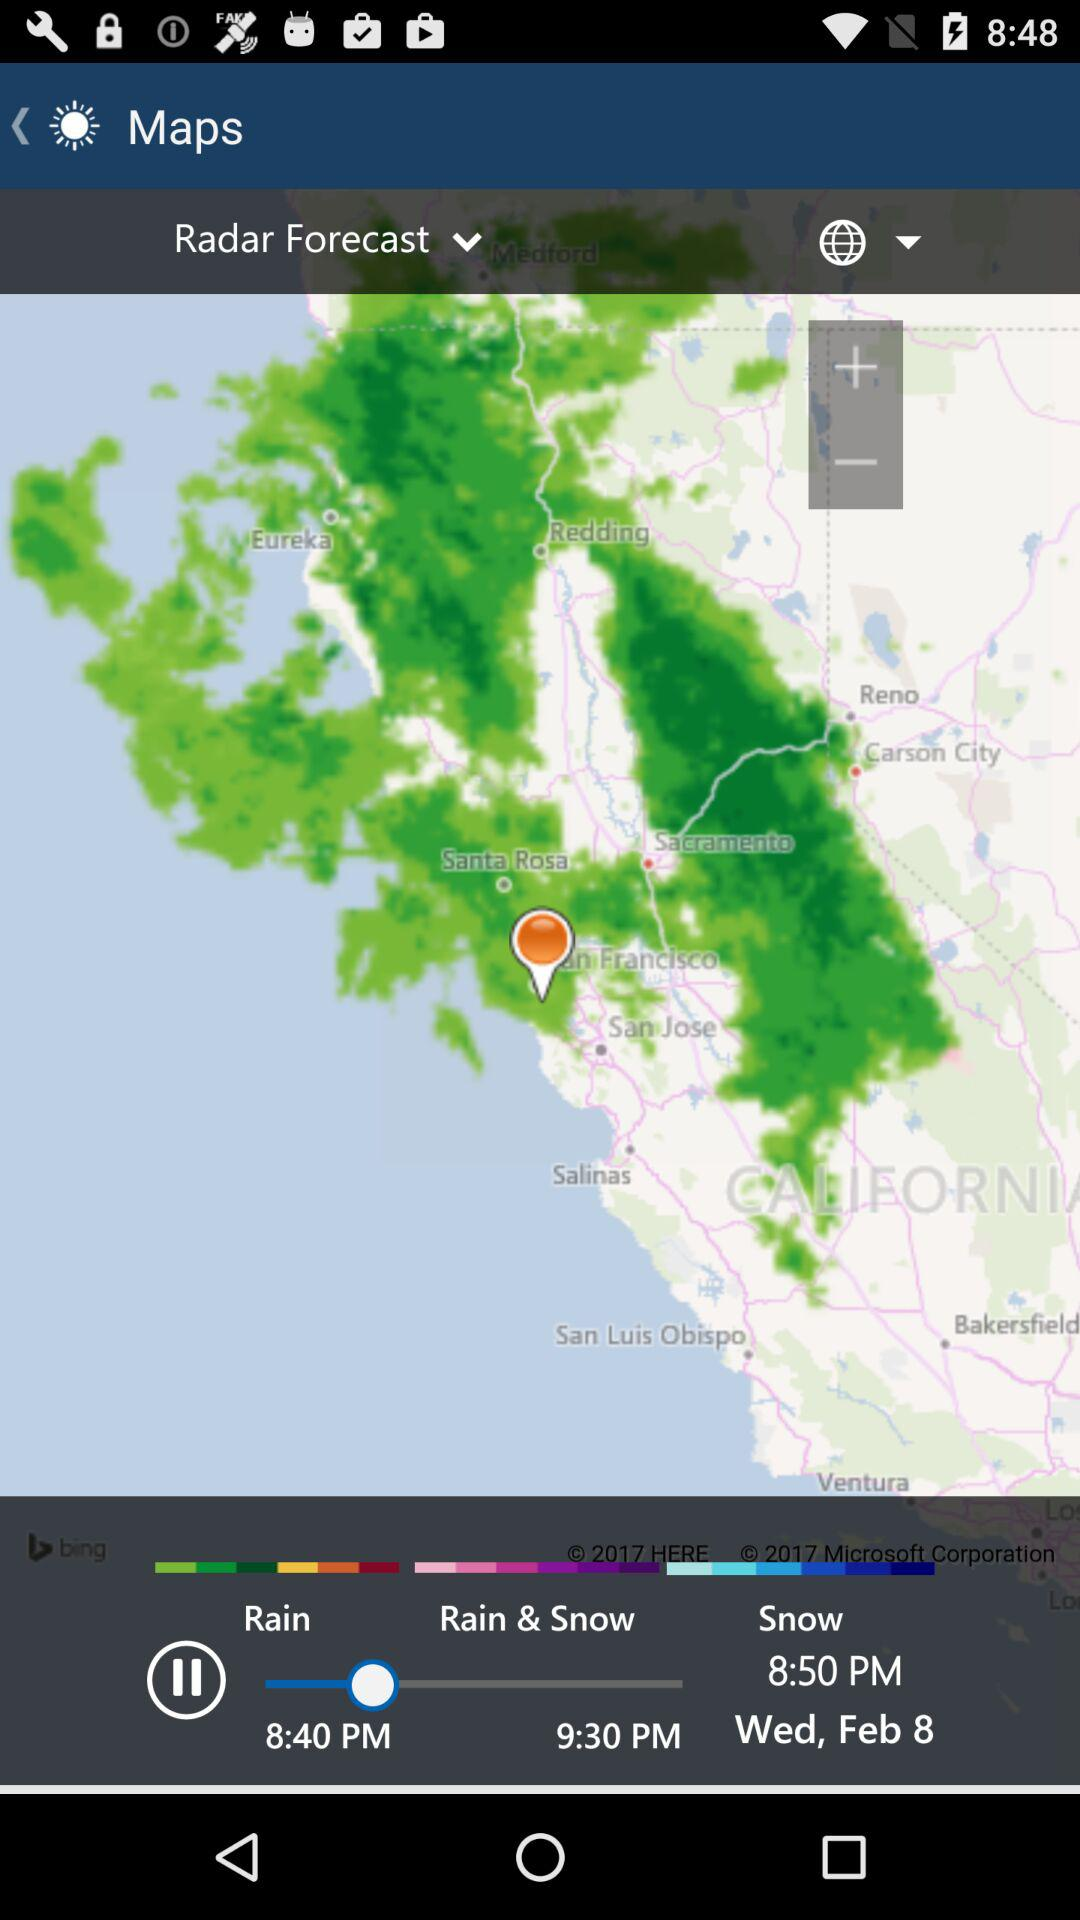At what time snow in showing?
When the provided information is insufficient, respond with <no answer>. <no answer> 